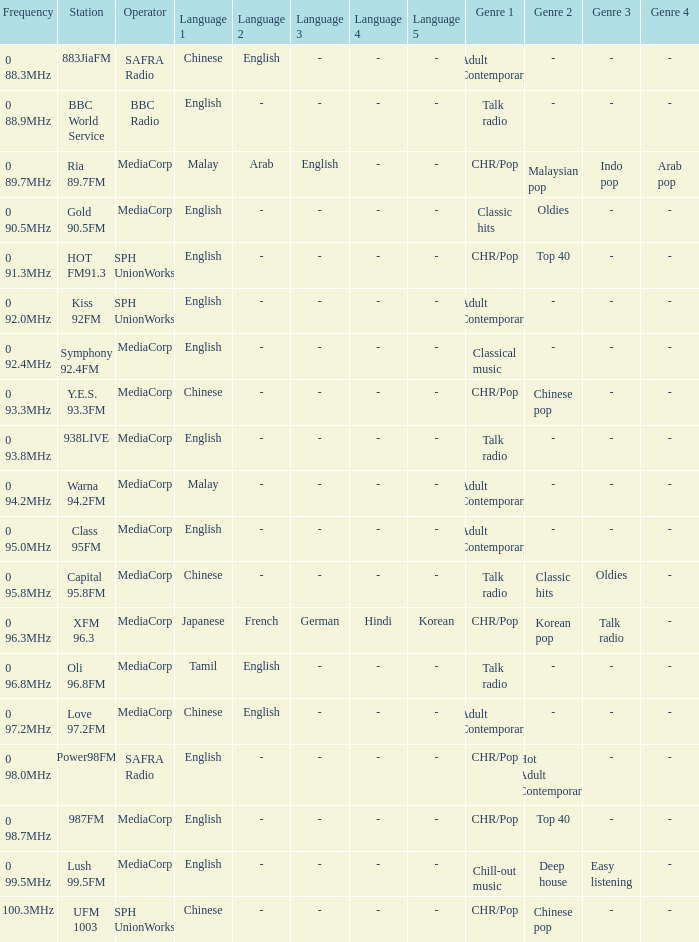What genre has a station of Class 95FM? Adult Contemporary. 